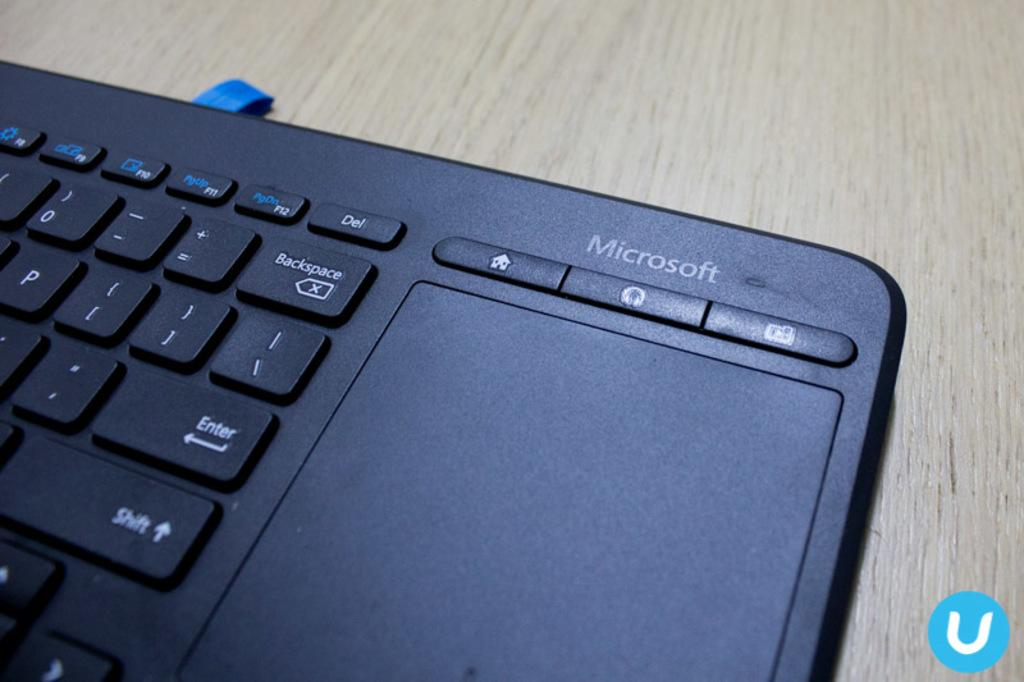<image>
Present a compact description of the photo's key features. A Microsoft keyboard that has a trackpad on it. 